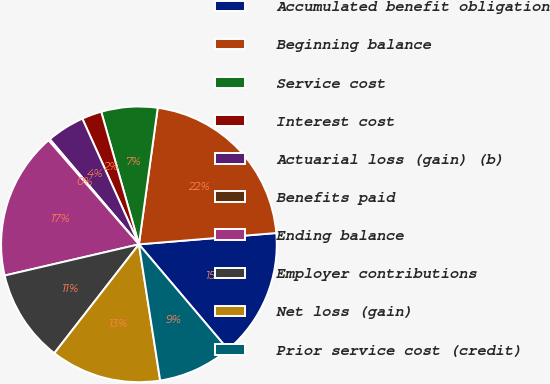<chart> <loc_0><loc_0><loc_500><loc_500><pie_chart><fcel>Accumulated benefit obligation<fcel>Beginning balance<fcel>Service cost<fcel>Interest cost<fcel>Actuarial loss (gain) (b)<fcel>Benefits paid<fcel>Ending balance<fcel>Employer contributions<fcel>Net loss (gain)<fcel>Prior service cost (credit)<nl><fcel>15.12%<fcel>21.51%<fcel>6.59%<fcel>2.32%<fcel>4.46%<fcel>0.19%<fcel>17.25%<fcel>10.85%<fcel>12.98%<fcel>8.72%<nl></chart> 